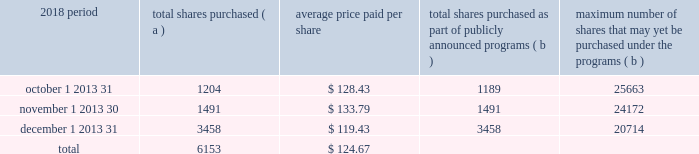The pnc financial services group , inc .
2013 form 10-k 29 part ii item 5 2013 market for registrant 2019s common equity , related stockholder matters and issuer purchases of equity securities ( a ) ( 1 ) our common stock is listed on the new york stock exchange and is traded under the symbol 201cpnc . 201d at the close of business on february 15 , 2019 , there were 53986 common shareholders of record .
Holders of pnc common stock are entitled to receive dividends when declared by our board of directors out of funds legally available for this purpose .
Our board of directors may not pay or set apart dividends on the common stock until dividends for all past dividend periods on any series of outstanding preferred stock and certain outstanding capital securities issued by the parent company have been paid or declared and set apart for payment .
The board of directors presently intends to continue the policy of paying quarterly cash dividends .
The amount of any future dividends will depend on economic and market conditions , our financial condition and operating results , and other factors , including contractual restrictions and applicable government regulations and policies ( such as those relating to the ability of bank and non-bank subsidiaries to pay dividends to the parent company and regulatory capital limitations ) .
The amount of our dividend is also currently subject to the results of the supervisory assessment of capital adequacy and capital planning processes undertaken by the federal reserve and our primary bank regulators as part of the comprehensive capital analysis and review ( ccar ) process as described in the supervision and regulation section in item 1 of this report .
The federal reserve has the power to prohibit us from paying dividends without its approval .
For further information concerning dividend restrictions and other factors that could limit our ability to pay dividends , as well as restrictions on loans , dividends or advances from bank subsidiaries to the parent company , see the supervision and regulation section in item 1 , item 1a risk factors , the liquidity and capital management portion of the risk management section in item 7 , and note 10 borrowed funds , note 15 equity and note 18 regulatory matters in the notes to consolidated financial statements in item 8 of this report , which we include here by reference .
We include here by reference the information regarding our compensation plans under which pnc equity securities are authorized for issuance as of december 31 , 2018 in the table ( with introductory paragraph and notes ) in item 12 of this report .
Our stock transfer agent and registrar is : computershare trust company , n.a .
250 royall street canton , ma 02021 800-982-7652 www.computershare.com/pnc registered shareholders may contact computershare regarding dividends and other shareholder services .
We include here by reference the information that appears under the common stock performance graph caption at the end of this item 5 .
( a ) ( 2 ) none .
( b ) not applicable .
( c ) details of our repurchases of pnc common stock during the fourth quarter of 2018 are included in the table : in thousands , except per share data 2018 period total shares purchased ( a ) average price paid per share total shares purchased as part of publicly announced programs ( b ) maximum number of shares that may yet be purchased under the programs ( b ) .
( a ) includes pnc common stock purchased in connection with our various employee benefit plans generally related to forfeitures of unvested restricted stock awards and shares used to cover employee payroll tax withholding requirements .
Note 11 employee benefit plans and note 12 stock based compensation plans in the notes to consolidated financial statements in item 8 of this report include additional information regarding our employee benefit and equity compensation plans that use pnc common stock .
( b ) on march 11 , 2015 , we announced that our board of directors approved a stock repurchase program authorization in the amount of 100 million shares of pnc common stock , effective april 1 , 2015 .
Repurchases are made in open market or privately negotiated transactions and the timing and exact amount of common stock repurchases will depend on a number of factors including , among others , market and general economic conditions , regulatory capital considerations , alternative uses of capital , the potential impact on our credit ratings , and contractual and regulatory limitations , including the results of the supervisory assessment of capital adequacy and capital planning processes undertaken by the federal reserve as part of the ccar process .
In june 2018 , we announced share repurchase programs of up to $ 2.0 billion for the four quarter period beginning with the third quarter of 2018 , including repurchases of up to $ 300 million related to stock issuances under employee benefit plans , in accordance with pnc's 2018 capital plan .
In november 2018 , we announced an increase to these previously announced programs in the amount of up to $ 900 million in additional common share repurchases .
The aggregate repurchase price of shares repurchased during the fourth quarter of 2018 was $ .8 billion .
See the liquidity and capital management portion of the risk management section in item 7 of this report for more information on the authorized share repurchase programs for the period july 1 , 2018 through june 30 , 2019 .
Http://www.computershare.com/pnc .
What was the reduction in average price per share for repurchases from the period november 1 2013 30 to december 1 2013 31? 
Computations: (133.79 - 119.43)
Answer: 14.36. 